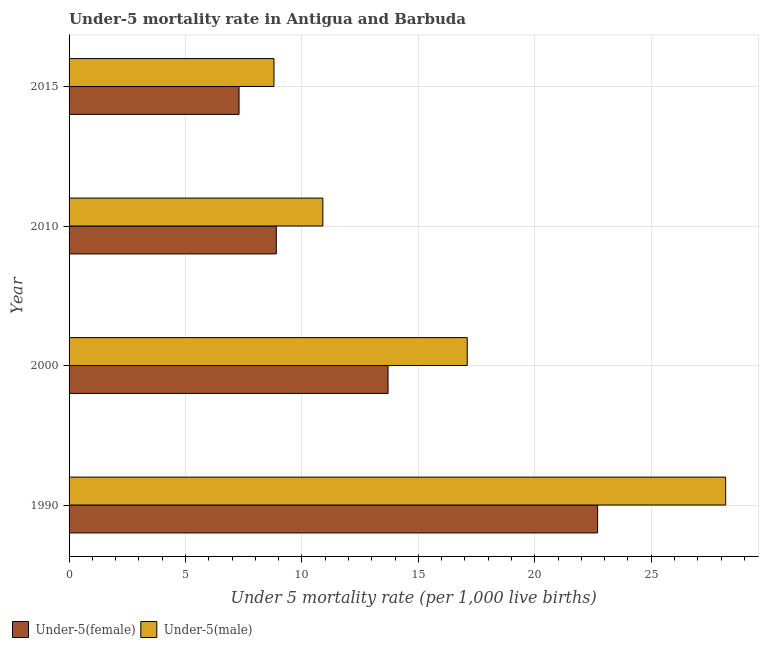How many different coloured bars are there?
Offer a very short reply. 2. How many groups of bars are there?
Give a very brief answer. 4. Are the number of bars per tick equal to the number of legend labels?
Give a very brief answer. Yes. How many bars are there on the 2nd tick from the top?
Ensure brevity in your answer.  2. What is the under-5 female mortality rate in 1990?
Ensure brevity in your answer.  22.7. Across all years, what is the maximum under-5 female mortality rate?
Your response must be concise. 22.7. Across all years, what is the minimum under-5 female mortality rate?
Your answer should be compact. 7.3. In which year was the under-5 male mortality rate minimum?
Make the answer very short. 2015. What is the total under-5 female mortality rate in the graph?
Provide a short and direct response. 52.6. What is the difference between the under-5 female mortality rate in 2010 and the under-5 male mortality rate in 2000?
Provide a short and direct response. -8.2. What is the average under-5 female mortality rate per year?
Ensure brevity in your answer.  13.15. In the year 1990, what is the difference between the under-5 female mortality rate and under-5 male mortality rate?
Keep it short and to the point. -5.5. What is the ratio of the under-5 female mortality rate in 1990 to that in 2010?
Offer a terse response. 2.55. Is the difference between the under-5 male mortality rate in 2010 and 2015 greater than the difference between the under-5 female mortality rate in 2010 and 2015?
Keep it short and to the point. Yes. What is the difference between the highest and the lowest under-5 male mortality rate?
Keep it short and to the point. 19.4. In how many years, is the under-5 male mortality rate greater than the average under-5 male mortality rate taken over all years?
Ensure brevity in your answer.  2. Is the sum of the under-5 female mortality rate in 1990 and 2000 greater than the maximum under-5 male mortality rate across all years?
Keep it short and to the point. Yes. What does the 2nd bar from the top in 2015 represents?
Ensure brevity in your answer.  Under-5(female). What does the 1st bar from the bottom in 1990 represents?
Give a very brief answer. Under-5(female). What is the difference between two consecutive major ticks on the X-axis?
Your answer should be very brief. 5. Are the values on the major ticks of X-axis written in scientific E-notation?
Provide a short and direct response. No. Where does the legend appear in the graph?
Keep it short and to the point. Bottom left. How many legend labels are there?
Your response must be concise. 2. What is the title of the graph?
Give a very brief answer. Under-5 mortality rate in Antigua and Barbuda. Does "Females" appear as one of the legend labels in the graph?
Keep it short and to the point. No. What is the label or title of the X-axis?
Keep it short and to the point. Under 5 mortality rate (per 1,0 live births). What is the label or title of the Y-axis?
Make the answer very short. Year. What is the Under 5 mortality rate (per 1,000 live births) in Under-5(female) in 1990?
Offer a terse response. 22.7. What is the Under 5 mortality rate (per 1,000 live births) in Under-5(male) in 1990?
Make the answer very short. 28.2. What is the Under 5 mortality rate (per 1,000 live births) in Under-5(female) in 2000?
Keep it short and to the point. 13.7. What is the Under 5 mortality rate (per 1,000 live births) of Under-5(male) in 2010?
Ensure brevity in your answer.  10.9. What is the Under 5 mortality rate (per 1,000 live births) in Under-5(male) in 2015?
Ensure brevity in your answer.  8.8. Across all years, what is the maximum Under 5 mortality rate (per 1,000 live births) in Under-5(female)?
Provide a short and direct response. 22.7. Across all years, what is the maximum Under 5 mortality rate (per 1,000 live births) in Under-5(male)?
Offer a terse response. 28.2. Across all years, what is the minimum Under 5 mortality rate (per 1,000 live births) of Under-5(female)?
Offer a very short reply. 7.3. Across all years, what is the minimum Under 5 mortality rate (per 1,000 live births) of Under-5(male)?
Give a very brief answer. 8.8. What is the total Under 5 mortality rate (per 1,000 live births) in Under-5(female) in the graph?
Your answer should be very brief. 52.6. What is the total Under 5 mortality rate (per 1,000 live births) in Under-5(male) in the graph?
Make the answer very short. 65. What is the difference between the Under 5 mortality rate (per 1,000 live births) in Under-5(female) in 1990 and that in 2000?
Your response must be concise. 9. What is the difference between the Under 5 mortality rate (per 1,000 live births) of Under-5(female) in 1990 and that in 2010?
Make the answer very short. 13.8. What is the difference between the Under 5 mortality rate (per 1,000 live births) of Under-5(male) in 1990 and that in 2010?
Your response must be concise. 17.3. What is the difference between the Under 5 mortality rate (per 1,000 live births) in Under-5(female) in 1990 and that in 2015?
Your answer should be very brief. 15.4. What is the difference between the Under 5 mortality rate (per 1,000 live births) in Under-5(male) in 1990 and that in 2015?
Make the answer very short. 19.4. What is the difference between the Under 5 mortality rate (per 1,000 live births) of Under-5(female) in 2000 and that in 2010?
Your answer should be very brief. 4.8. What is the difference between the Under 5 mortality rate (per 1,000 live births) in Under-5(male) in 2000 and that in 2015?
Give a very brief answer. 8.3. What is the difference between the Under 5 mortality rate (per 1,000 live births) in Under-5(female) in 1990 and the Under 5 mortality rate (per 1,000 live births) in Under-5(male) in 2000?
Provide a succinct answer. 5.6. What is the difference between the Under 5 mortality rate (per 1,000 live births) in Under-5(female) in 2000 and the Under 5 mortality rate (per 1,000 live births) in Under-5(male) in 2010?
Offer a very short reply. 2.8. What is the difference between the Under 5 mortality rate (per 1,000 live births) in Under-5(female) in 2000 and the Under 5 mortality rate (per 1,000 live births) in Under-5(male) in 2015?
Keep it short and to the point. 4.9. What is the difference between the Under 5 mortality rate (per 1,000 live births) of Under-5(female) in 2010 and the Under 5 mortality rate (per 1,000 live births) of Under-5(male) in 2015?
Provide a short and direct response. 0.1. What is the average Under 5 mortality rate (per 1,000 live births) of Under-5(female) per year?
Your answer should be compact. 13.15. What is the average Under 5 mortality rate (per 1,000 live births) of Under-5(male) per year?
Keep it short and to the point. 16.25. In the year 2000, what is the difference between the Under 5 mortality rate (per 1,000 live births) of Under-5(female) and Under 5 mortality rate (per 1,000 live births) of Under-5(male)?
Provide a succinct answer. -3.4. In the year 2010, what is the difference between the Under 5 mortality rate (per 1,000 live births) in Under-5(female) and Under 5 mortality rate (per 1,000 live births) in Under-5(male)?
Keep it short and to the point. -2. What is the ratio of the Under 5 mortality rate (per 1,000 live births) in Under-5(female) in 1990 to that in 2000?
Your response must be concise. 1.66. What is the ratio of the Under 5 mortality rate (per 1,000 live births) in Under-5(male) in 1990 to that in 2000?
Provide a succinct answer. 1.65. What is the ratio of the Under 5 mortality rate (per 1,000 live births) of Under-5(female) in 1990 to that in 2010?
Keep it short and to the point. 2.55. What is the ratio of the Under 5 mortality rate (per 1,000 live births) in Under-5(male) in 1990 to that in 2010?
Offer a very short reply. 2.59. What is the ratio of the Under 5 mortality rate (per 1,000 live births) in Under-5(female) in 1990 to that in 2015?
Offer a terse response. 3.11. What is the ratio of the Under 5 mortality rate (per 1,000 live births) of Under-5(male) in 1990 to that in 2015?
Your answer should be very brief. 3.2. What is the ratio of the Under 5 mortality rate (per 1,000 live births) of Under-5(female) in 2000 to that in 2010?
Make the answer very short. 1.54. What is the ratio of the Under 5 mortality rate (per 1,000 live births) of Under-5(male) in 2000 to that in 2010?
Make the answer very short. 1.57. What is the ratio of the Under 5 mortality rate (per 1,000 live births) of Under-5(female) in 2000 to that in 2015?
Keep it short and to the point. 1.88. What is the ratio of the Under 5 mortality rate (per 1,000 live births) of Under-5(male) in 2000 to that in 2015?
Make the answer very short. 1.94. What is the ratio of the Under 5 mortality rate (per 1,000 live births) of Under-5(female) in 2010 to that in 2015?
Offer a terse response. 1.22. What is the ratio of the Under 5 mortality rate (per 1,000 live births) in Under-5(male) in 2010 to that in 2015?
Provide a short and direct response. 1.24. What is the difference between the highest and the second highest Under 5 mortality rate (per 1,000 live births) of Under-5(male)?
Make the answer very short. 11.1. What is the difference between the highest and the lowest Under 5 mortality rate (per 1,000 live births) of Under-5(male)?
Ensure brevity in your answer.  19.4. 